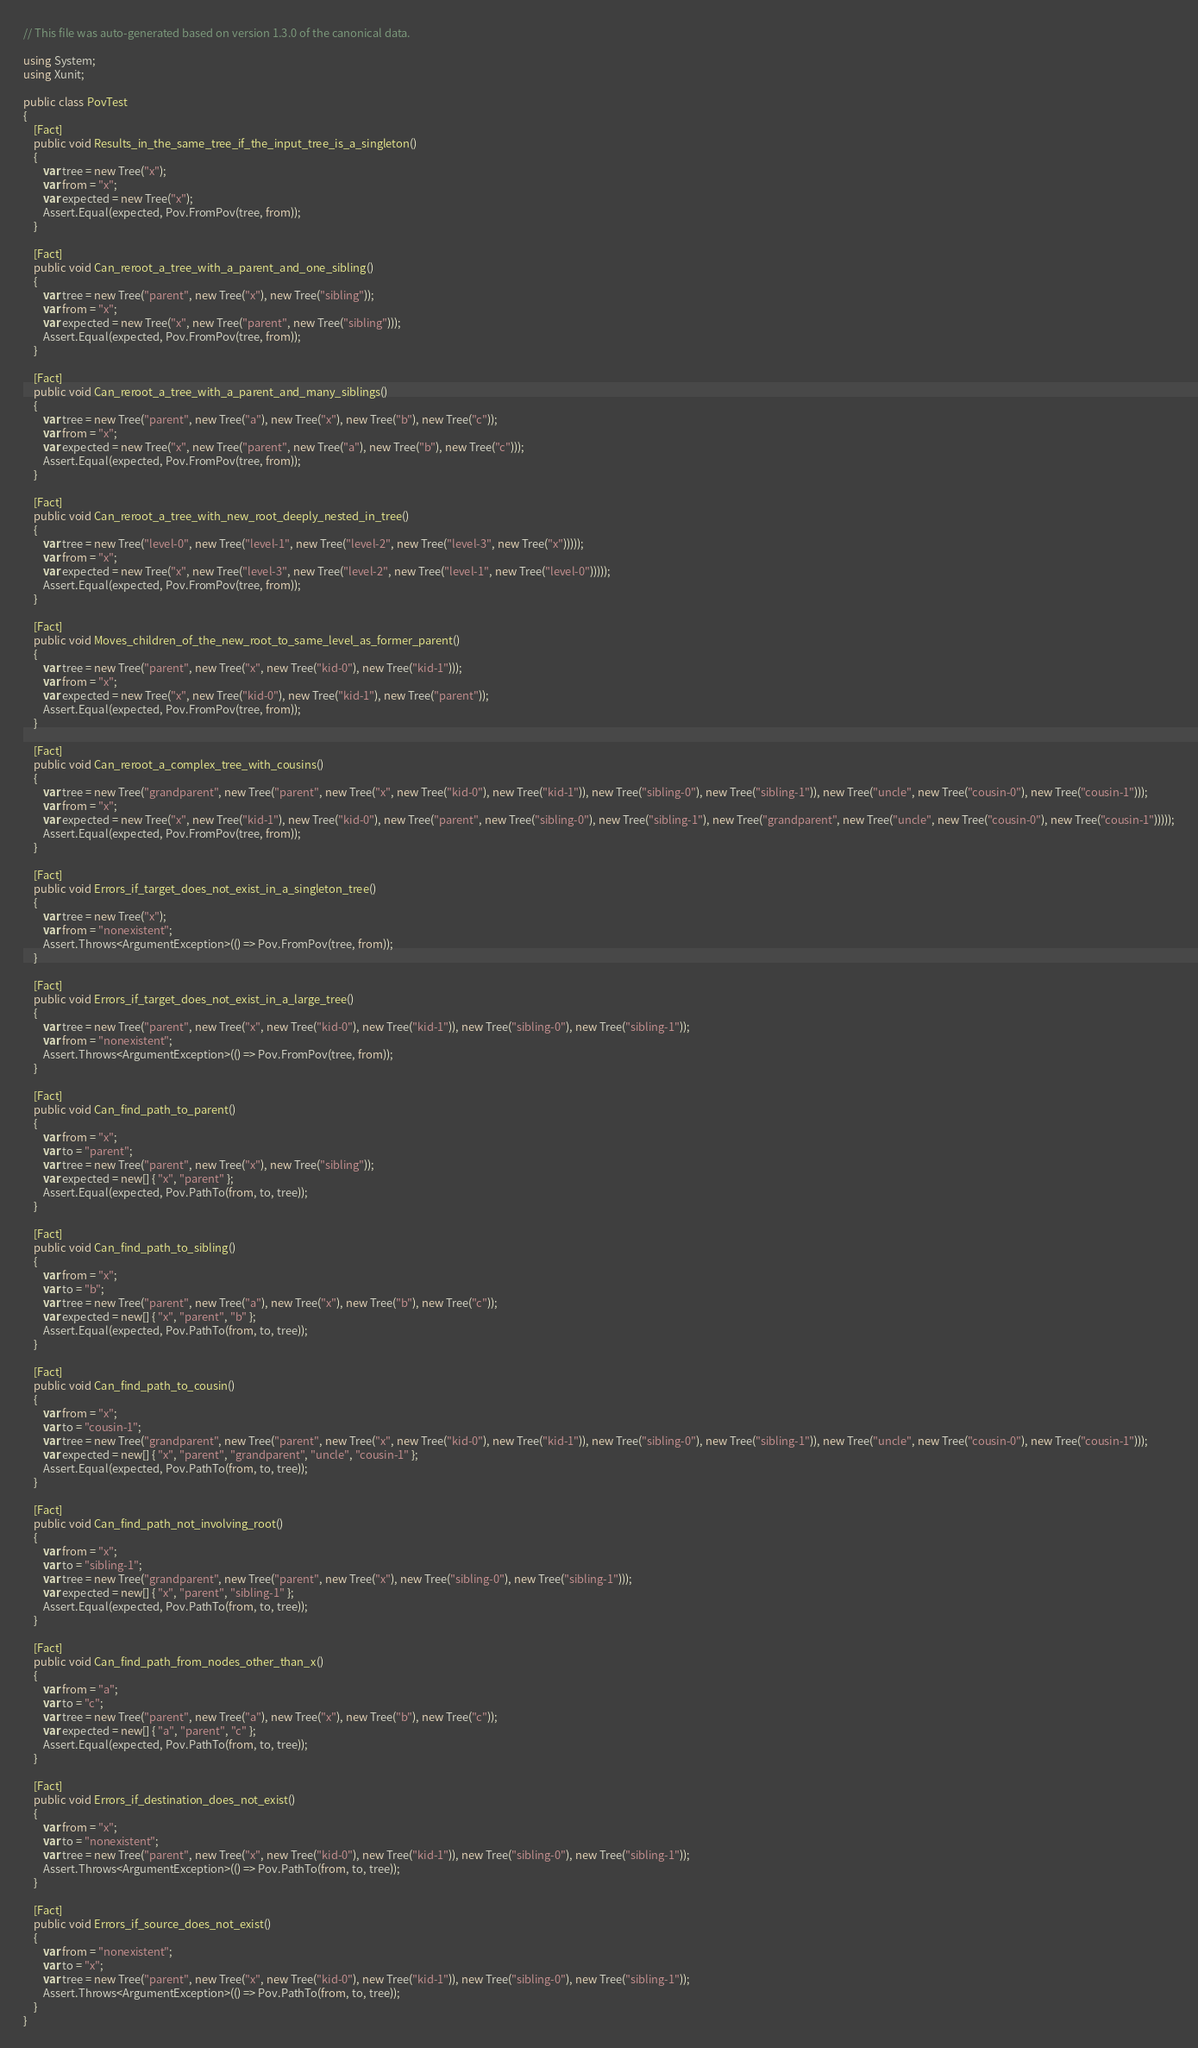<code> <loc_0><loc_0><loc_500><loc_500><_C#_>// This file was auto-generated based on version 1.3.0 of the canonical data.

using System;
using Xunit;

public class PovTest
{
    [Fact]
    public void Results_in_the_same_tree_if_the_input_tree_is_a_singleton()
    {
        var tree = new Tree("x");
        var from = "x";
        var expected = new Tree("x");
        Assert.Equal(expected, Pov.FromPov(tree, from));
    }

    [Fact]
    public void Can_reroot_a_tree_with_a_parent_and_one_sibling()
    {
        var tree = new Tree("parent", new Tree("x"), new Tree("sibling"));
        var from = "x";
        var expected = new Tree("x", new Tree("parent", new Tree("sibling")));
        Assert.Equal(expected, Pov.FromPov(tree, from));
    }

    [Fact]
    public void Can_reroot_a_tree_with_a_parent_and_many_siblings()
    {
        var tree = new Tree("parent", new Tree("a"), new Tree("x"), new Tree("b"), new Tree("c"));
        var from = "x";
        var expected = new Tree("x", new Tree("parent", new Tree("a"), new Tree("b"), new Tree("c")));
        Assert.Equal(expected, Pov.FromPov(tree, from));
    }

    [Fact]
    public void Can_reroot_a_tree_with_new_root_deeply_nested_in_tree()
    {
        var tree = new Tree("level-0", new Tree("level-1", new Tree("level-2", new Tree("level-3", new Tree("x")))));
        var from = "x";
        var expected = new Tree("x", new Tree("level-3", new Tree("level-2", new Tree("level-1", new Tree("level-0")))));
        Assert.Equal(expected, Pov.FromPov(tree, from));
    }

    [Fact]
    public void Moves_children_of_the_new_root_to_same_level_as_former_parent()
    {
        var tree = new Tree("parent", new Tree("x", new Tree("kid-0"), new Tree("kid-1")));
        var from = "x";
        var expected = new Tree("x", new Tree("kid-0"), new Tree("kid-1"), new Tree("parent"));
        Assert.Equal(expected, Pov.FromPov(tree, from));
    }

    [Fact]
    public void Can_reroot_a_complex_tree_with_cousins()
    {
        var tree = new Tree("grandparent", new Tree("parent", new Tree("x", new Tree("kid-0"), new Tree("kid-1")), new Tree("sibling-0"), new Tree("sibling-1")), new Tree("uncle", new Tree("cousin-0"), new Tree("cousin-1")));
        var from = "x";
        var expected = new Tree("x", new Tree("kid-1"), new Tree("kid-0"), new Tree("parent", new Tree("sibling-0"), new Tree("sibling-1"), new Tree("grandparent", new Tree("uncle", new Tree("cousin-0"), new Tree("cousin-1")))));
        Assert.Equal(expected, Pov.FromPov(tree, from));
    }

    [Fact]
    public void Errors_if_target_does_not_exist_in_a_singleton_tree()
    {
        var tree = new Tree("x");
        var from = "nonexistent";
        Assert.Throws<ArgumentException>(() => Pov.FromPov(tree, from));
    }

    [Fact]
    public void Errors_if_target_does_not_exist_in_a_large_tree()
    {
        var tree = new Tree("parent", new Tree("x", new Tree("kid-0"), new Tree("kid-1")), new Tree("sibling-0"), new Tree("sibling-1"));
        var from = "nonexistent";
        Assert.Throws<ArgumentException>(() => Pov.FromPov(tree, from));
    }

    [Fact]
    public void Can_find_path_to_parent()
    {
        var from = "x";
        var to = "parent";
        var tree = new Tree("parent", new Tree("x"), new Tree("sibling"));
        var expected = new[] { "x", "parent" };
        Assert.Equal(expected, Pov.PathTo(from, to, tree));
    }

    [Fact]
    public void Can_find_path_to_sibling()
    {
        var from = "x";
        var to = "b";
        var tree = new Tree("parent", new Tree("a"), new Tree("x"), new Tree("b"), new Tree("c"));
        var expected = new[] { "x", "parent", "b" };
        Assert.Equal(expected, Pov.PathTo(from, to, tree));
    }

    [Fact]
    public void Can_find_path_to_cousin()
    {
        var from = "x";
        var to = "cousin-1";
        var tree = new Tree("grandparent", new Tree("parent", new Tree("x", new Tree("kid-0"), new Tree("kid-1")), new Tree("sibling-0"), new Tree("sibling-1")), new Tree("uncle", new Tree("cousin-0"), new Tree("cousin-1")));
        var expected = new[] { "x", "parent", "grandparent", "uncle", "cousin-1" };
        Assert.Equal(expected, Pov.PathTo(from, to, tree));
    }

    [Fact]
    public void Can_find_path_not_involving_root()
    {
        var from = "x";
        var to = "sibling-1";
        var tree = new Tree("grandparent", new Tree("parent", new Tree("x"), new Tree("sibling-0"), new Tree("sibling-1")));
        var expected = new[] { "x", "parent", "sibling-1" };
        Assert.Equal(expected, Pov.PathTo(from, to, tree));
    }

    [Fact]
    public void Can_find_path_from_nodes_other_than_x()
    {
        var from = "a";
        var to = "c";
        var tree = new Tree("parent", new Tree("a"), new Tree("x"), new Tree("b"), new Tree("c"));
        var expected = new[] { "a", "parent", "c" };
        Assert.Equal(expected, Pov.PathTo(from, to, tree));
    }

    [Fact]
    public void Errors_if_destination_does_not_exist()
    {
        var from = "x";
        var to = "nonexistent";
        var tree = new Tree("parent", new Tree("x", new Tree("kid-0"), new Tree("kid-1")), new Tree("sibling-0"), new Tree("sibling-1"));
        Assert.Throws<ArgumentException>(() => Pov.PathTo(from, to, tree));
    }

    [Fact]
    public void Errors_if_source_does_not_exist()
    {
        var from = "nonexistent";
        var to = "x";
        var tree = new Tree("parent", new Tree("x", new Tree("kid-0"), new Tree("kid-1")), new Tree("sibling-0"), new Tree("sibling-1"));
        Assert.Throws<ArgumentException>(() => Pov.PathTo(from, to, tree));
    }
}</code> 